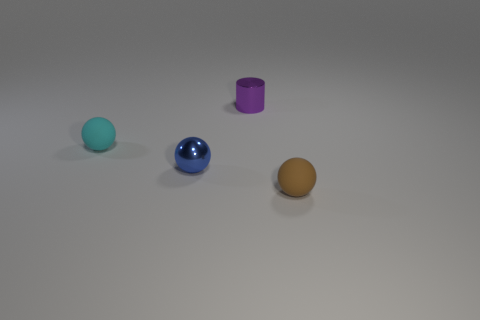There is a small matte object right of the metal object behind the tiny rubber object that is on the left side of the tiny brown sphere; what is its shape?
Provide a succinct answer. Sphere. The other matte object that is the same shape as the small cyan rubber thing is what color?
Make the answer very short. Brown. There is a small rubber ball that is behind the tiny sphere that is to the right of the purple metallic thing; how many spheres are in front of it?
Your answer should be very brief. 2. What number of small objects are either purple shiny cylinders or gray matte cylinders?
Keep it short and to the point. 1. Are the small object that is right of the purple cylinder and the cyan object made of the same material?
Offer a very short reply. Yes. What material is the tiny sphere that is right of the shiny thing behind the small matte object behind the small brown matte thing made of?
Provide a short and direct response. Rubber. How many shiny objects are small objects or big purple balls?
Give a very brief answer. 2. Are there any small yellow cylinders?
Make the answer very short. No. What color is the rubber ball in front of the matte ball behind the blue thing?
Offer a very short reply. Brown. How many other objects are there of the same color as the shiny cylinder?
Provide a succinct answer. 0. 